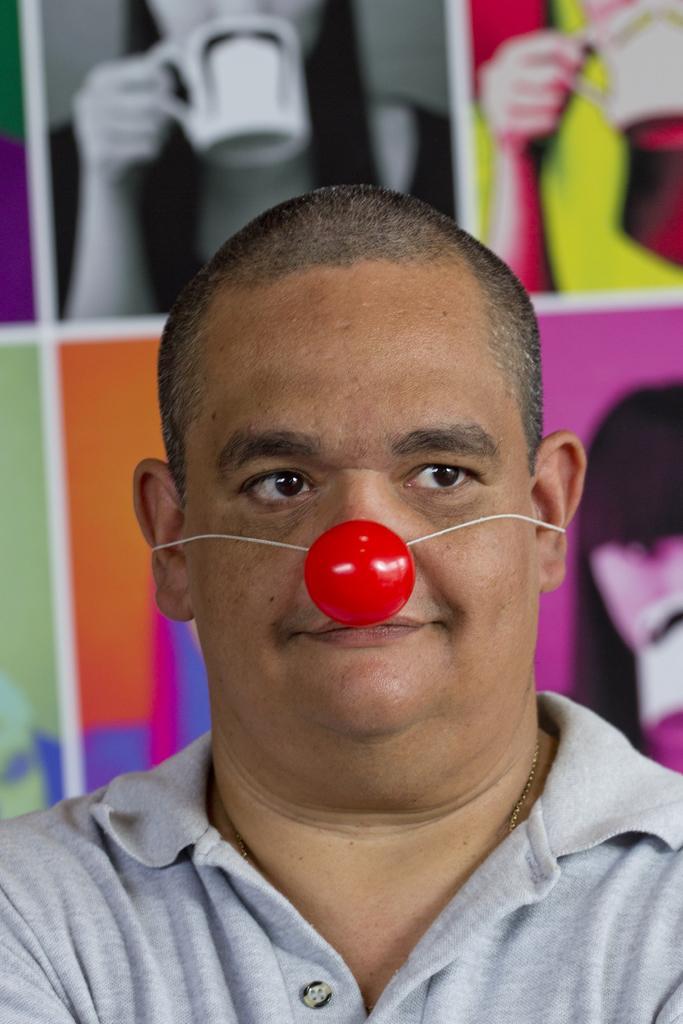Please provide a concise description of this image. In this image I can see a person. He is wearing red color object on his face. Back Side I can see a colorful frame. 